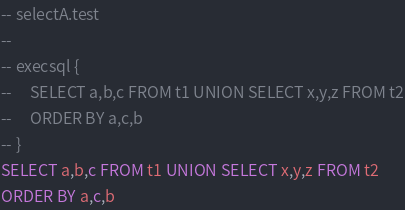Convert code to text. <code><loc_0><loc_0><loc_500><loc_500><_SQL_>-- selectA.test
-- 
-- execsql {
--     SELECT a,b,c FROM t1 UNION SELECT x,y,z FROM t2
--     ORDER BY a,c,b
-- }
SELECT a,b,c FROM t1 UNION SELECT x,y,z FROM t2
ORDER BY a,c,b</code> 